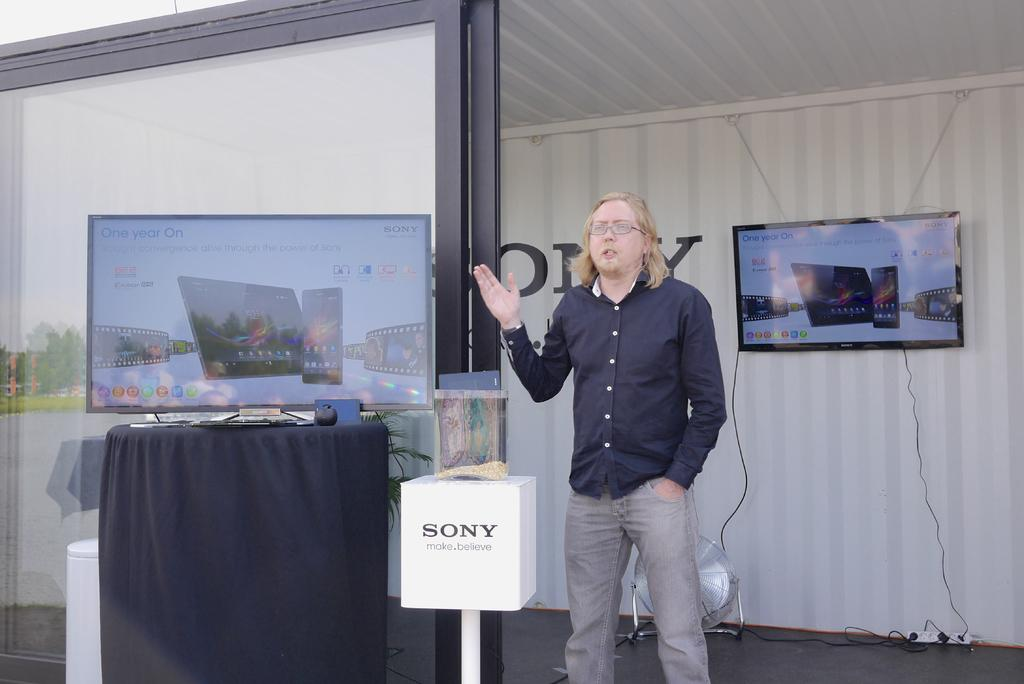<image>
Provide a brief description of the given image. A man is on a stage talking about Sony. 